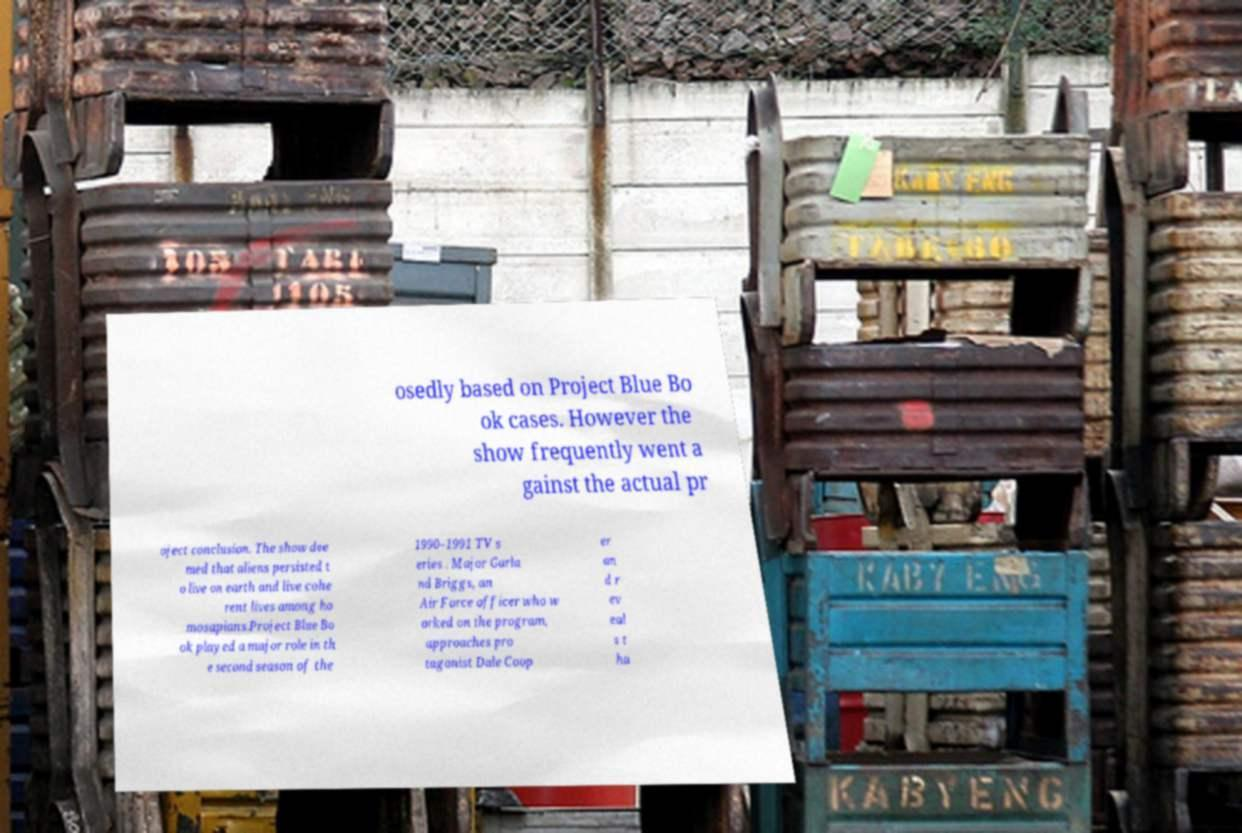What messages or text are displayed in this image? I need them in a readable, typed format. osedly based on Project Blue Bo ok cases. However the show frequently went a gainst the actual pr oject conclusion. The show dee med that aliens persisted t o live on earth and live cohe rent lives among ho mosapians.Project Blue Bo ok played a major role in th e second season of the 1990–1991 TV s eries . Major Garla nd Briggs, an Air Force officer who w orked on the program, approaches pro tagonist Dale Coop er an d r ev eal s t ha 